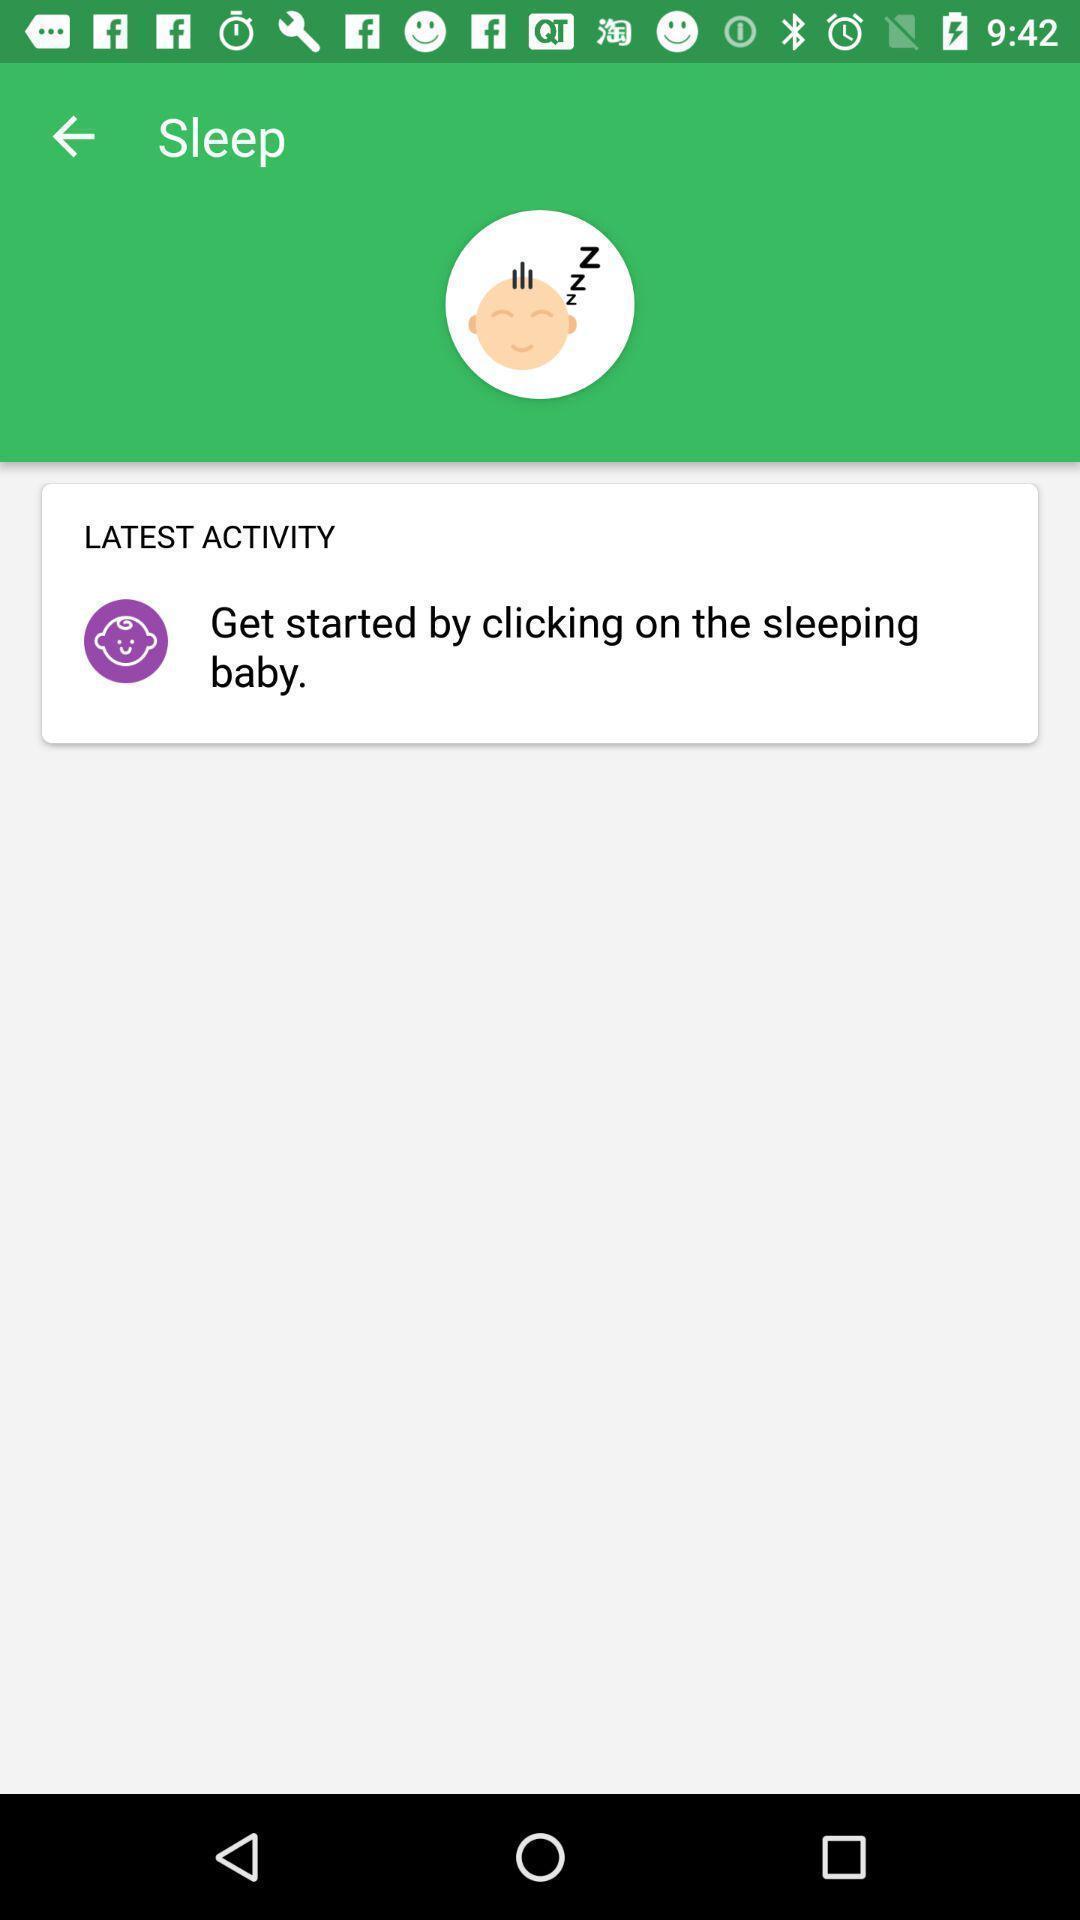Describe the content in this image. Screen displaying contents in activity page. 